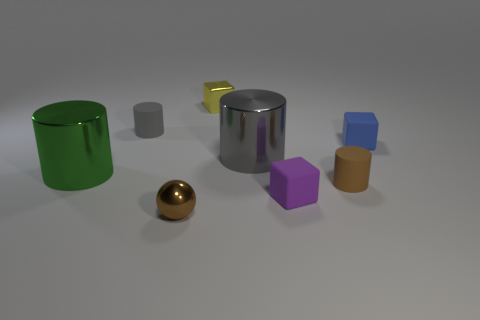Subtract all big green cylinders. How many cylinders are left? 3 Add 1 big things. How many objects exist? 9 Subtract all balls. How many objects are left? 7 Subtract all cyan spheres. How many gray cylinders are left? 2 Subtract 1 spheres. How many spheres are left? 0 Subtract all green spheres. Subtract all gray cylinders. How many spheres are left? 1 Subtract all large matte cubes. Subtract all small purple things. How many objects are left? 7 Add 7 metallic cylinders. How many metallic cylinders are left? 9 Add 8 tiny brown rubber objects. How many tiny brown rubber objects exist? 9 Subtract all yellow blocks. How many blocks are left? 2 